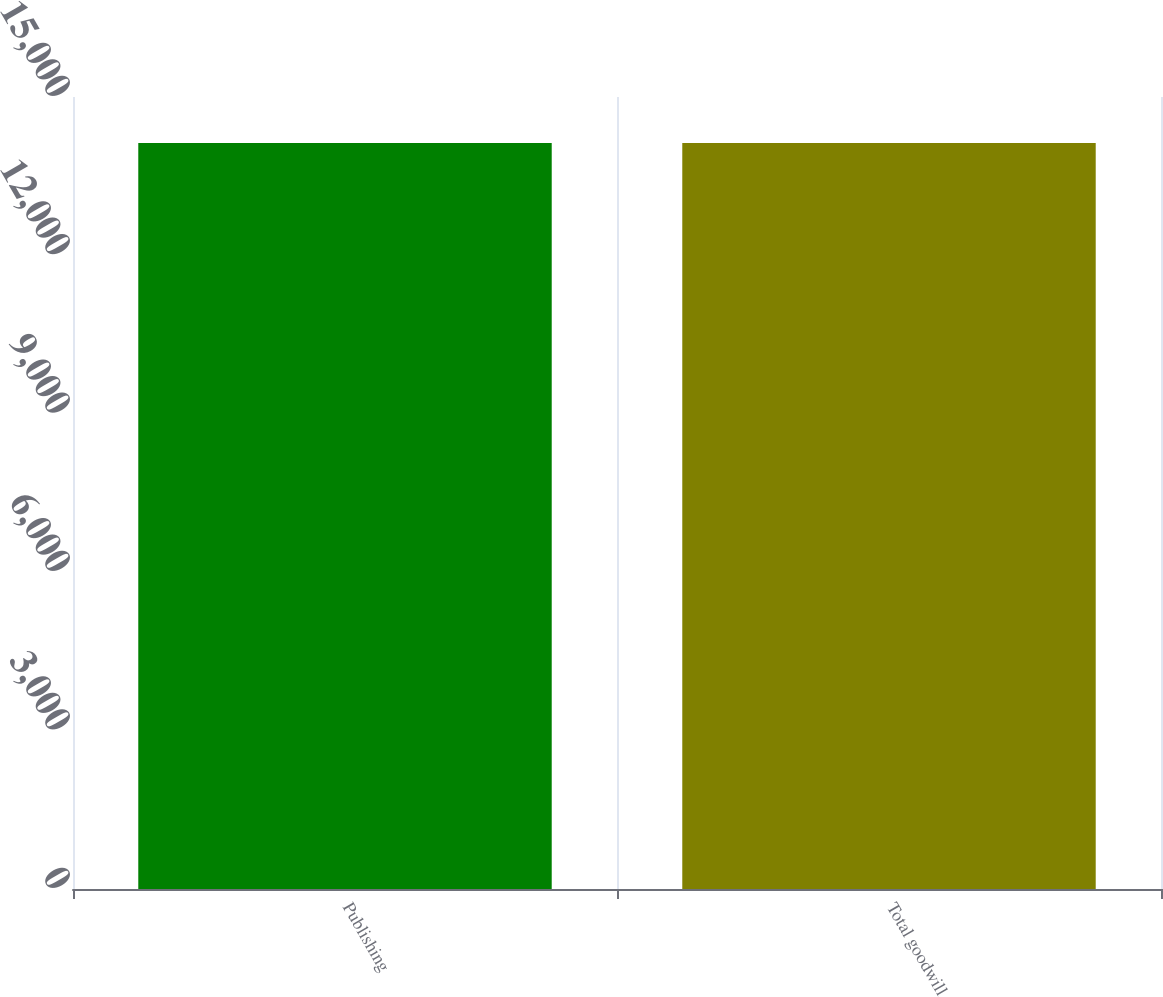Convert chart. <chart><loc_0><loc_0><loc_500><loc_500><bar_chart><fcel>Publishing<fcel>Total goodwill<nl><fcel>14129<fcel>14129.1<nl></chart> 